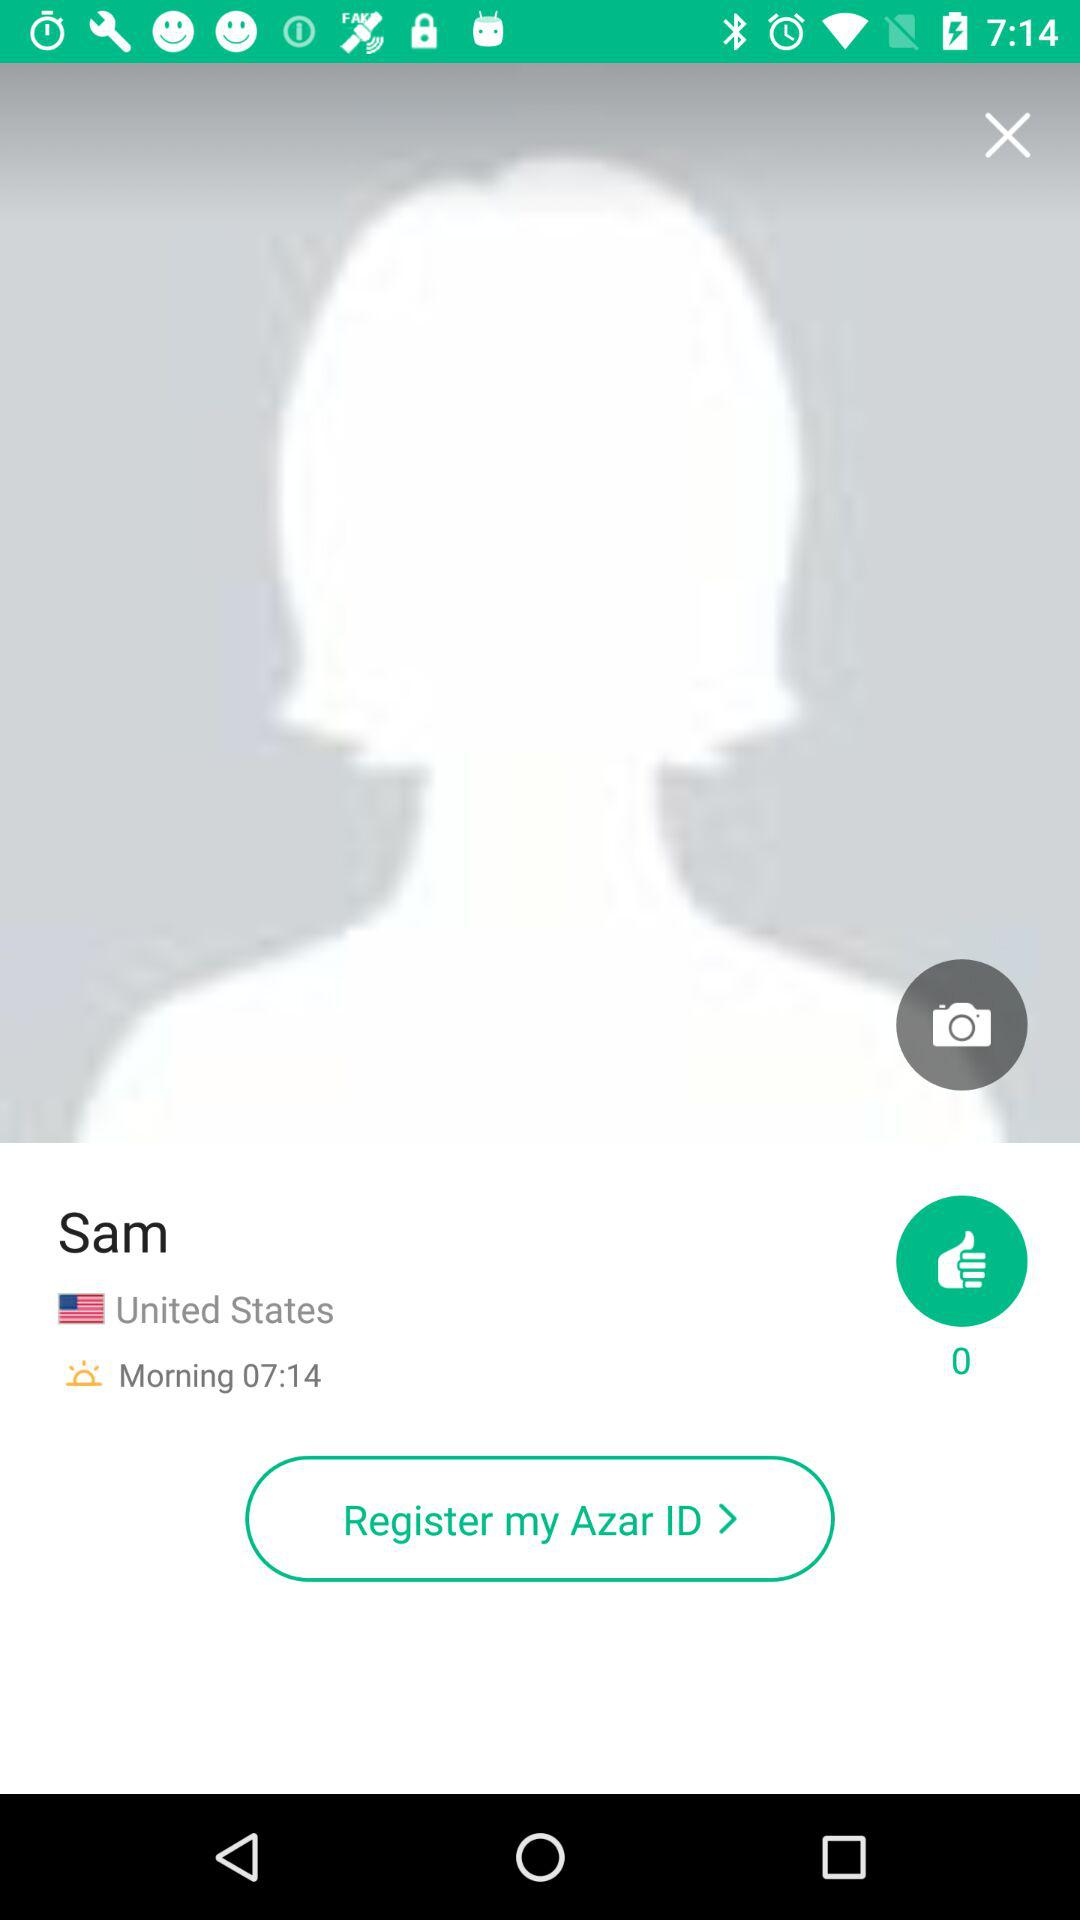How many likes are there? There are 0 likes. 